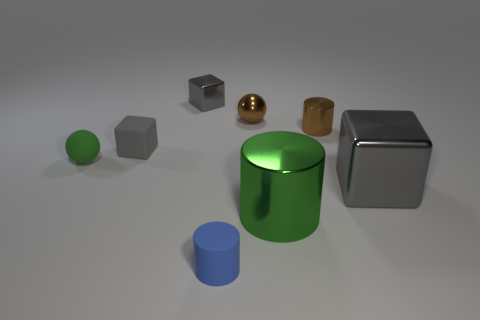Are any tiny cyan things visible? No, there are no tiny cyan objects in the image. The closest object in color is the larger green cylindrical shape towards the center. 